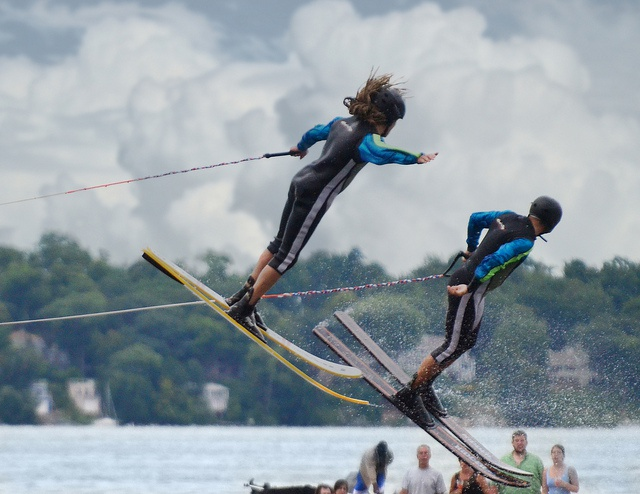Describe the objects in this image and their specific colors. I can see people in darkgray, black, gray, and navy tones, people in darkgray, black, gray, and navy tones, skis in darkgray, gray, tan, and black tones, skis in darkgray, gray, and lightgray tones, and people in darkgray and gray tones in this image. 